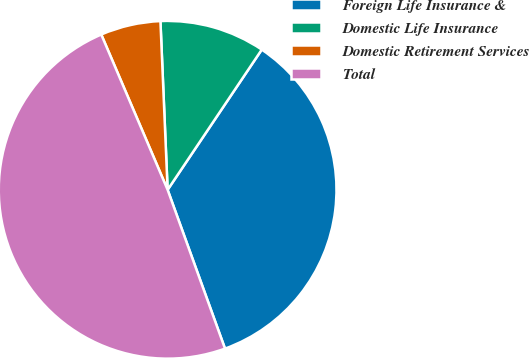Convert chart to OTSL. <chart><loc_0><loc_0><loc_500><loc_500><pie_chart><fcel>Foreign Life Insurance &<fcel>Domestic Life Insurance<fcel>Domestic Retirement Services<fcel>Total<nl><fcel>35.07%<fcel>10.09%<fcel>5.75%<fcel>49.09%<nl></chart> 